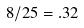Convert formula to latex. <formula><loc_0><loc_0><loc_500><loc_500>8 / 2 5 = . 3 2</formula> 